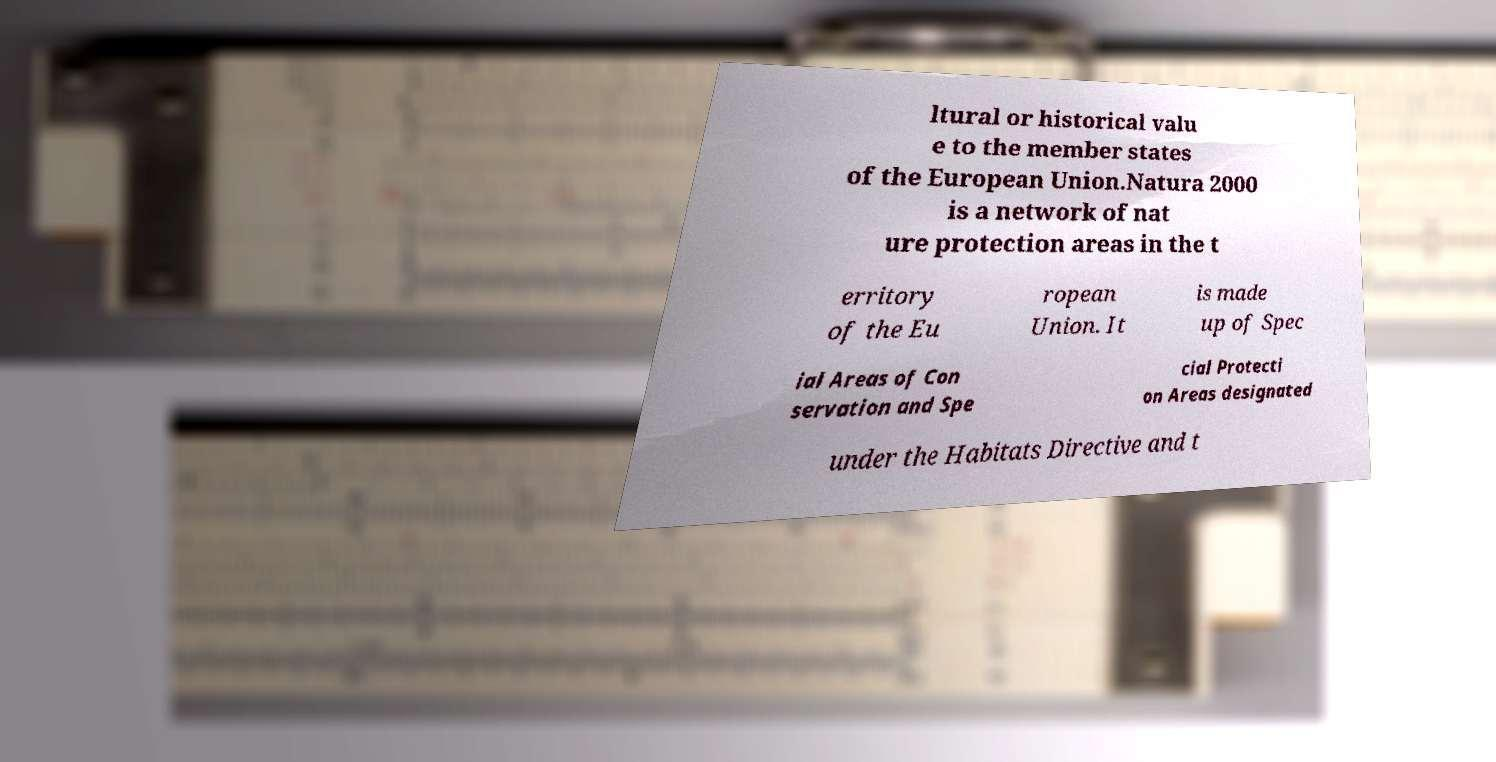Please identify and transcribe the text found in this image. ltural or historical valu e to the member states of the European Union.Natura 2000 is a network of nat ure protection areas in the t erritory of the Eu ropean Union. It is made up of Spec ial Areas of Con servation and Spe cial Protecti on Areas designated under the Habitats Directive and t 